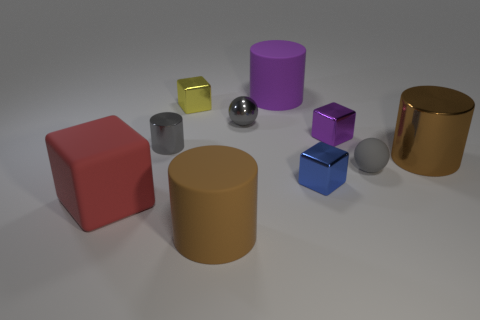Subtract all cylinders. How many objects are left? 6 Add 4 small purple shiny cubes. How many small purple shiny cubes are left? 5 Add 6 large cylinders. How many large cylinders exist? 9 Subtract 1 purple cylinders. How many objects are left? 9 Subtract all purple cylinders. Subtract all large red cubes. How many objects are left? 8 